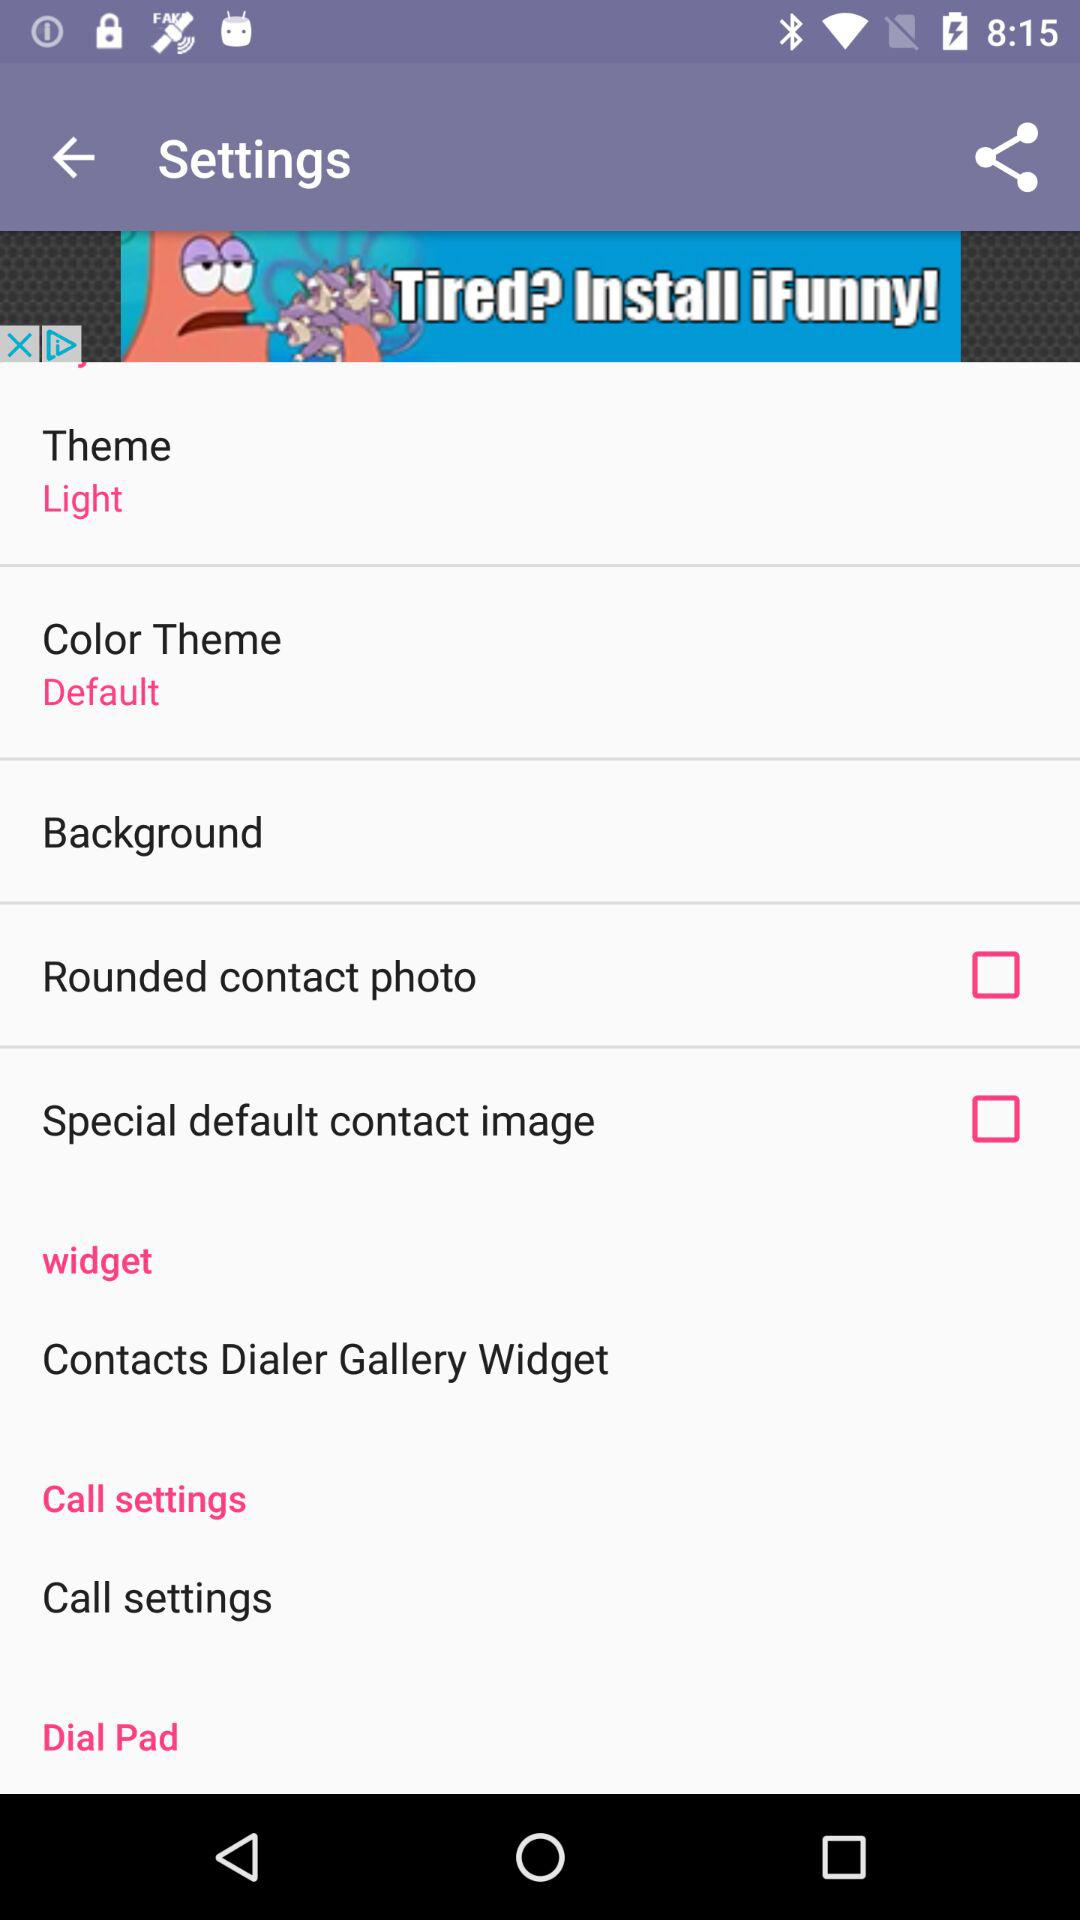What is the setting for the color theme? The setting is "Default". 